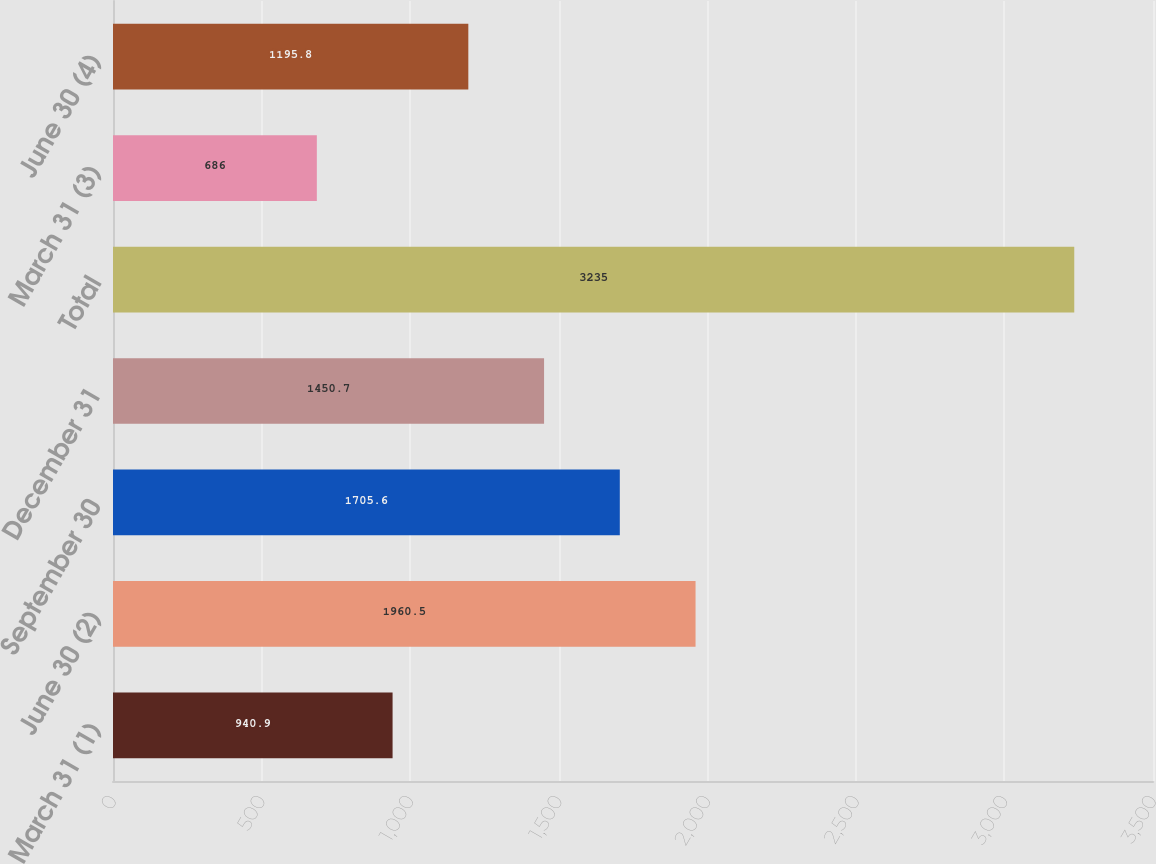<chart> <loc_0><loc_0><loc_500><loc_500><bar_chart><fcel>March 31 (1)<fcel>June 30 (2)<fcel>September 30<fcel>December 31<fcel>Total<fcel>March 31 (3)<fcel>June 30 (4)<nl><fcel>940.9<fcel>1960.5<fcel>1705.6<fcel>1450.7<fcel>3235<fcel>686<fcel>1195.8<nl></chart> 